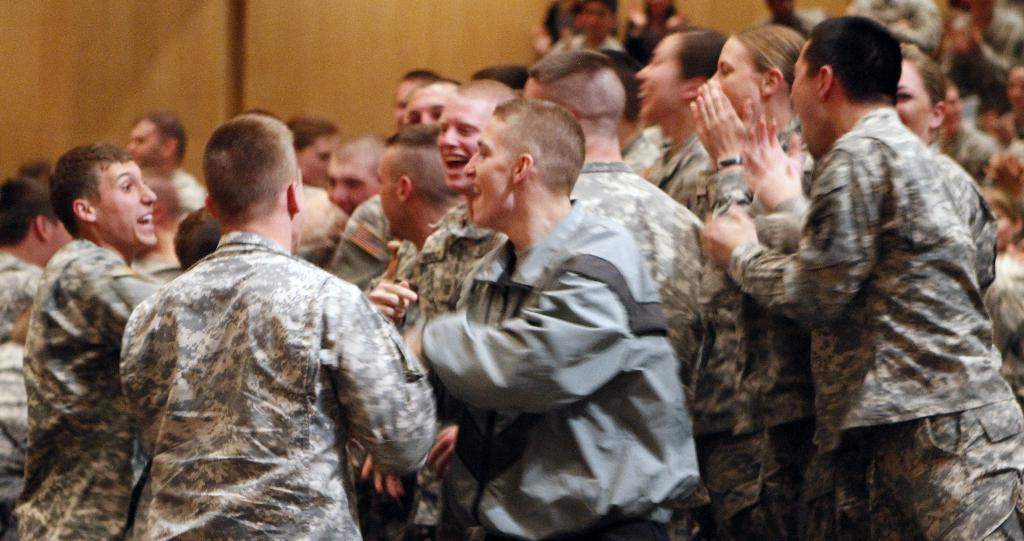What is happening in the image? There is a group of people standing in the image. How are the people in the group positioned? The people in the group are standing. What can be seen in the background of the image? There is a wooden wall in the background of the image. What type of camera is the guide using to take a picture of the group? There is no camera or guide present in the image; it only shows a group of people standing with a wooden wall in the background. 